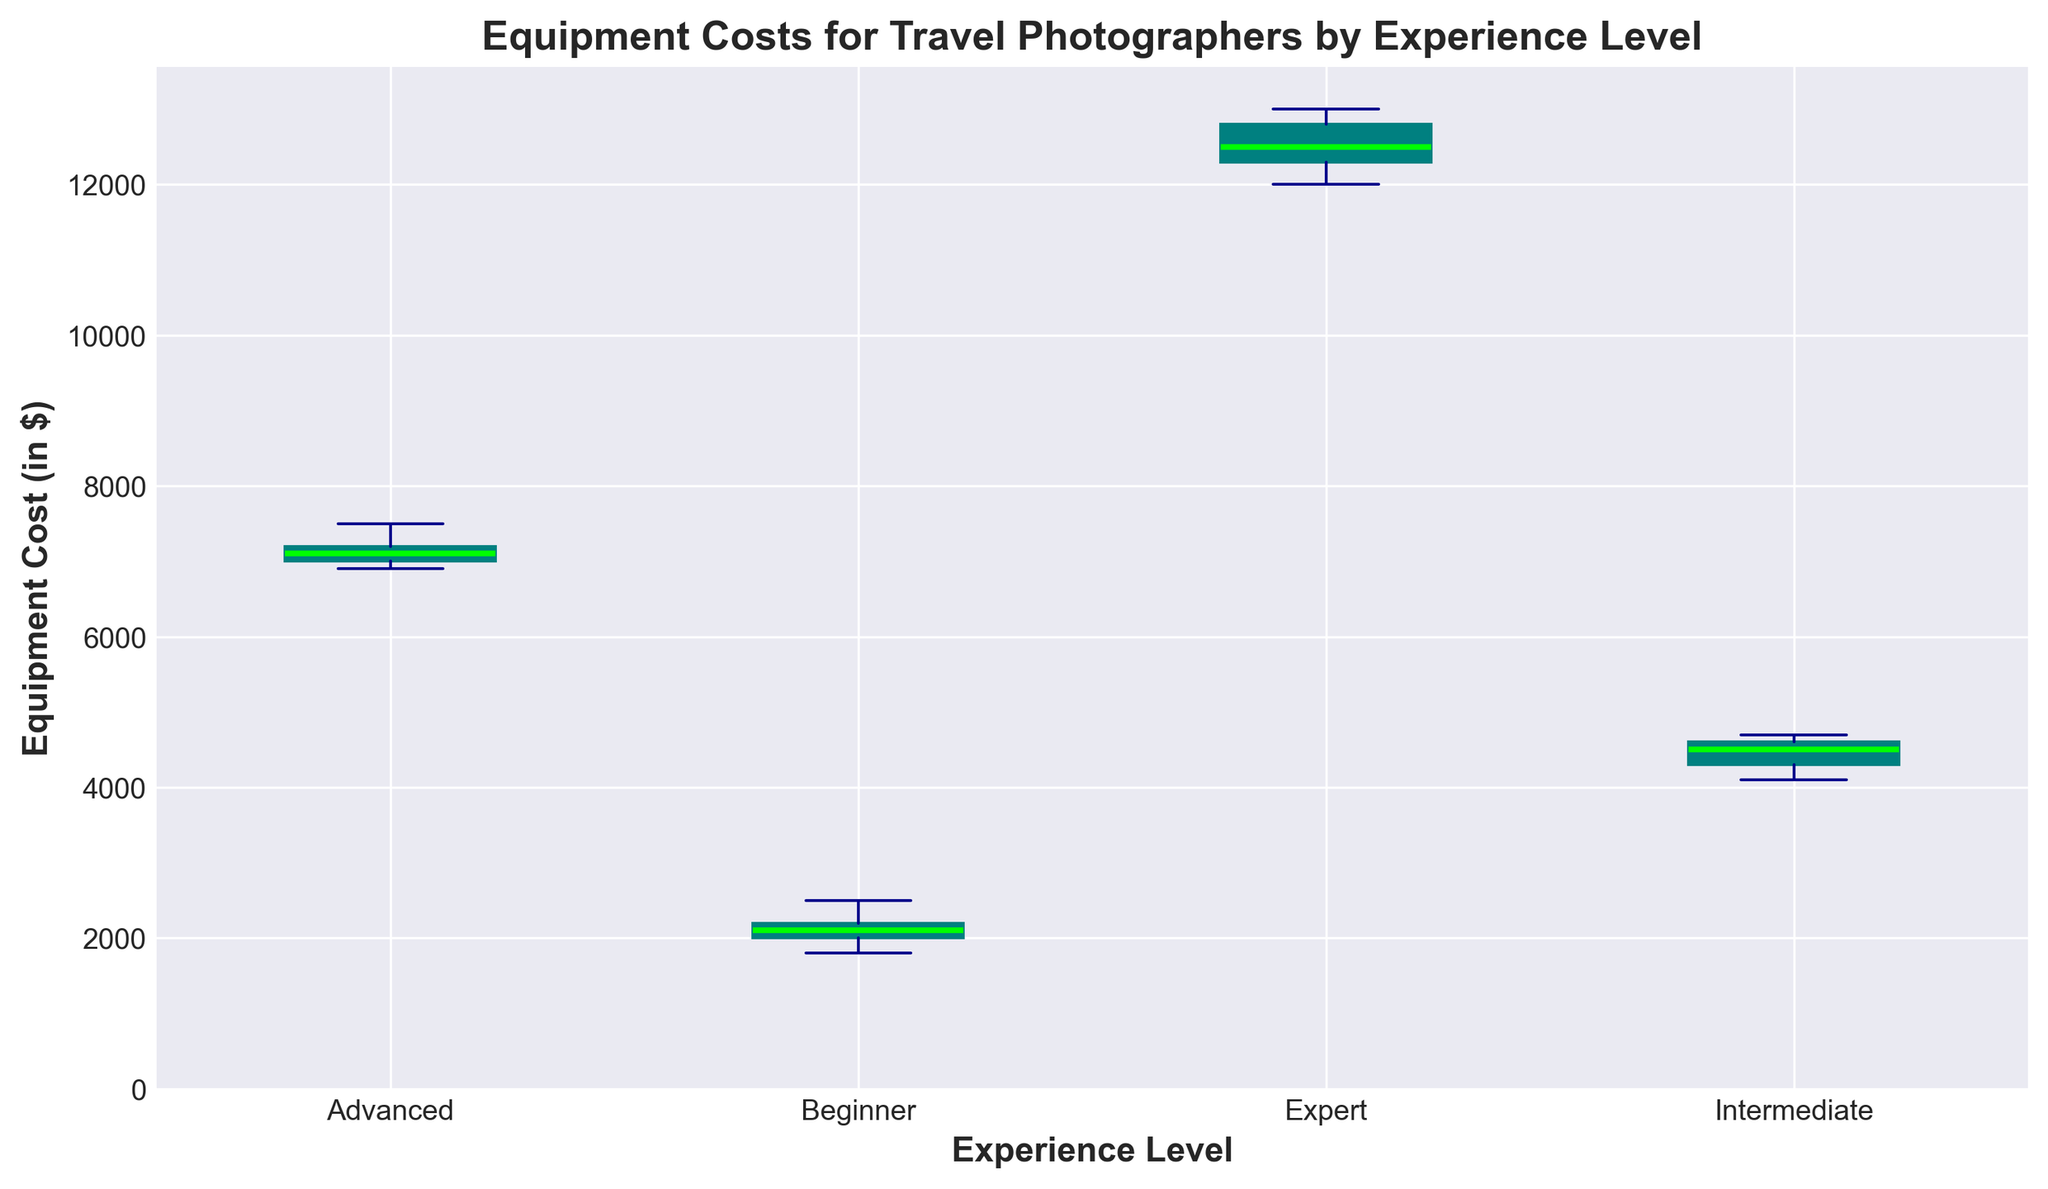What's the median Equipment Cost for Beginner photographers? The median is the middle value when the data points are ordered from lowest to highest. For Beginners: [1800, 2000, 2100, 2200, 2500]. The middle value is 2100.
Answer: 2100 Which Experience Level has the highest median Equipment Cost? Look at the medians for each experience level. The highest median line is for Experts.
Answer: Expert How does the range of Equipment Costs for Intermediate photographers compare to that of Advanced photographers? For Intermediates, the range is the difference between the highest and lowest values: 4700 - 4100 = 600. For Advanced, it's 7500 - 6900 = 600. Both ranges are the same.
Answer: Same What is the interquartile range (IQR) of Equipment Costs for Experts? IQR is the difference between the third quartile (Q3) and the first quartile (Q1). For Experts: Q3 is about 12800 and Q1 is about 12300. So, IQR = 12800 - 12300 = 500.
Answer: 500 Which Experience Level group has the least variation in Equipment Costs? Variation can be seen by the height of the box (IQR). The smallest height is for Advanced photographers.
Answer: Advanced What are the whiskers' range for Beginner photographers? The whiskers extend to the minimum and maximum non-outlier values. For Beginner photographers, the minimum is 1800 and the maximum is 2500.
Answer: 1800 to 2500 By how much does the average Equipment Cost of Expert photographers exceed that of Beginner photographers? The average values are not shown, but can be estimated to find the difference. For Experts, it's around 12580. For Beginners, it's around 2120. Difference: 12580 - 2120 = 10460.
Answer: 10460 Among all groups, which has the largest spread between the minimum and maximum values? The spread is seen through the length of the whiskers. Expert photographers have the largest spread from around 12000 to 13000, which is 13000 - 12000 = 1000.
Answer: Expert Which Experience Level has the smallest median Equipment Cost? The median is the horizontal line inside the box for each group. Beginners have the smallest median at 2100.
Answer: Beginner How many outliers are there in the Intermediate group? Outliers are marked as red circles. There are no outliers in the Intermediate group.
Answer: 0 